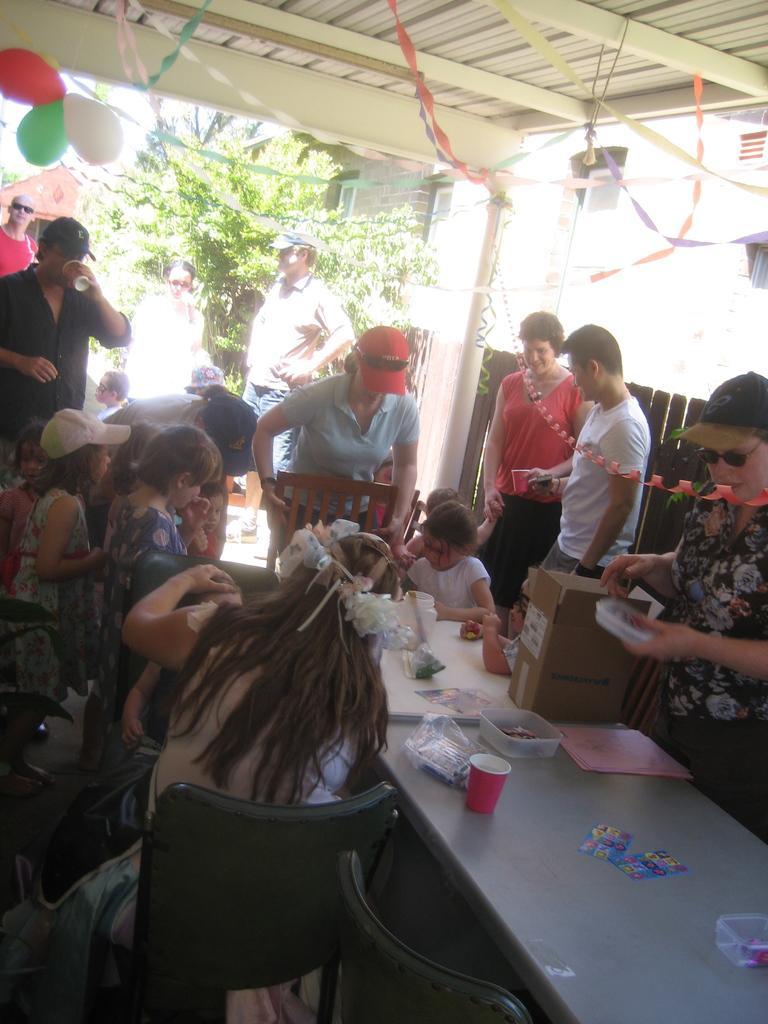Describe this image in one or two sentences. In the picture it looks like a party there are group of people all are enjoying the food, in the background there is a tree, the weather is also sunny and also a building. 